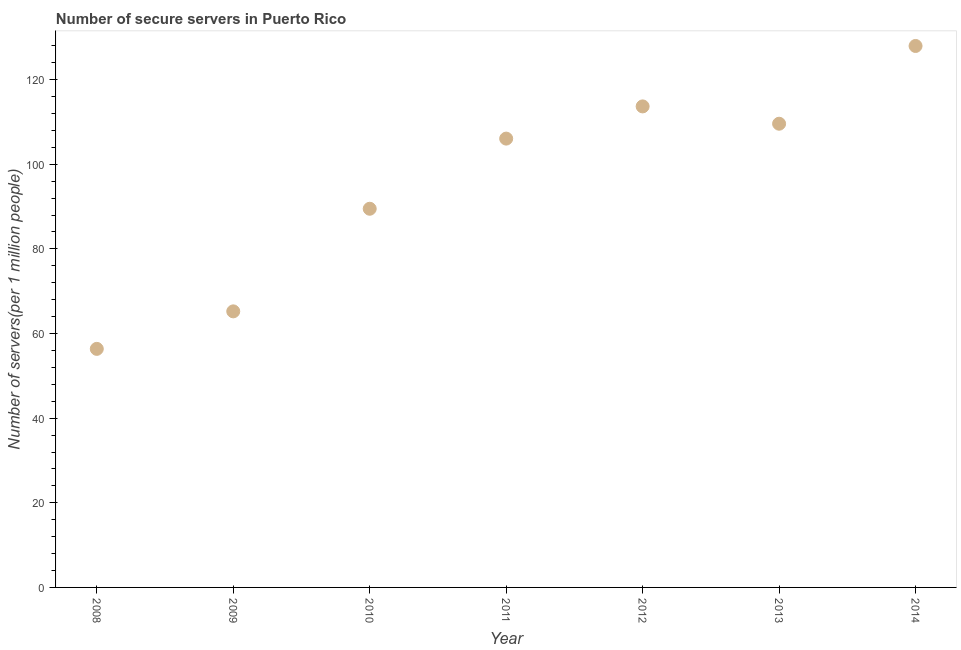What is the number of secure internet servers in 2014?
Your answer should be very brief. 127.95. Across all years, what is the maximum number of secure internet servers?
Provide a short and direct response. 127.95. Across all years, what is the minimum number of secure internet servers?
Offer a terse response. 56.37. In which year was the number of secure internet servers maximum?
Your response must be concise. 2014. In which year was the number of secure internet servers minimum?
Make the answer very short. 2008. What is the sum of the number of secure internet servers?
Your response must be concise. 668.32. What is the difference between the number of secure internet servers in 2010 and 2013?
Ensure brevity in your answer.  -20.09. What is the average number of secure internet servers per year?
Offer a terse response. 95.47. What is the median number of secure internet servers?
Your answer should be compact. 106.05. In how many years, is the number of secure internet servers greater than 104 ?
Your response must be concise. 4. Do a majority of the years between 2012 and 2010 (inclusive) have number of secure internet servers greater than 56 ?
Ensure brevity in your answer.  No. What is the ratio of the number of secure internet servers in 2009 to that in 2012?
Your answer should be compact. 0.57. What is the difference between the highest and the second highest number of secure internet servers?
Provide a succinct answer. 14.28. Is the sum of the number of secure internet servers in 2009 and 2013 greater than the maximum number of secure internet servers across all years?
Your answer should be very brief. Yes. What is the difference between the highest and the lowest number of secure internet servers?
Provide a short and direct response. 71.58. Does the number of secure internet servers monotonically increase over the years?
Keep it short and to the point. No. How many dotlines are there?
Your answer should be compact. 1. Are the values on the major ticks of Y-axis written in scientific E-notation?
Give a very brief answer. No. Does the graph contain any zero values?
Keep it short and to the point. No. Does the graph contain grids?
Keep it short and to the point. No. What is the title of the graph?
Ensure brevity in your answer.  Number of secure servers in Puerto Rico. What is the label or title of the Y-axis?
Give a very brief answer. Number of servers(per 1 million people). What is the Number of servers(per 1 million people) in 2008?
Make the answer very short. 56.37. What is the Number of servers(per 1 million people) in 2009?
Your answer should be very brief. 65.23. What is the Number of servers(per 1 million people) in 2010?
Your response must be concise. 89.48. What is the Number of servers(per 1 million people) in 2011?
Your answer should be very brief. 106.05. What is the Number of servers(per 1 million people) in 2012?
Keep it short and to the point. 113.67. What is the Number of servers(per 1 million people) in 2013?
Give a very brief answer. 109.57. What is the Number of servers(per 1 million people) in 2014?
Give a very brief answer. 127.95. What is the difference between the Number of servers(per 1 million people) in 2008 and 2009?
Make the answer very short. -8.86. What is the difference between the Number of servers(per 1 million people) in 2008 and 2010?
Provide a short and direct response. -33.11. What is the difference between the Number of servers(per 1 million people) in 2008 and 2011?
Offer a terse response. -49.68. What is the difference between the Number of servers(per 1 million people) in 2008 and 2012?
Your response must be concise. -57.3. What is the difference between the Number of servers(per 1 million people) in 2008 and 2013?
Provide a short and direct response. -53.2. What is the difference between the Number of servers(per 1 million people) in 2008 and 2014?
Offer a very short reply. -71.58. What is the difference between the Number of servers(per 1 million people) in 2009 and 2010?
Offer a very short reply. -24.25. What is the difference between the Number of servers(per 1 million people) in 2009 and 2011?
Keep it short and to the point. -40.82. What is the difference between the Number of servers(per 1 million people) in 2009 and 2012?
Offer a terse response. -48.43. What is the difference between the Number of servers(per 1 million people) in 2009 and 2013?
Ensure brevity in your answer.  -44.34. What is the difference between the Number of servers(per 1 million people) in 2009 and 2014?
Your answer should be very brief. -62.71. What is the difference between the Number of servers(per 1 million people) in 2010 and 2011?
Provide a succinct answer. -16.58. What is the difference between the Number of servers(per 1 million people) in 2010 and 2012?
Your answer should be compact. -24.19. What is the difference between the Number of servers(per 1 million people) in 2010 and 2013?
Give a very brief answer. -20.09. What is the difference between the Number of servers(per 1 million people) in 2010 and 2014?
Give a very brief answer. -38.47. What is the difference between the Number of servers(per 1 million people) in 2011 and 2012?
Make the answer very short. -7.61. What is the difference between the Number of servers(per 1 million people) in 2011 and 2013?
Your answer should be compact. -3.52. What is the difference between the Number of servers(per 1 million people) in 2011 and 2014?
Offer a very short reply. -21.89. What is the difference between the Number of servers(per 1 million people) in 2012 and 2013?
Offer a terse response. 4.09. What is the difference between the Number of servers(per 1 million people) in 2012 and 2014?
Make the answer very short. -14.28. What is the difference between the Number of servers(per 1 million people) in 2013 and 2014?
Your response must be concise. -18.37. What is the ratio of the Number of servers(per 1 million people) in 2008 to that in 2009?
Offer a very short reply. 0.86. What is the ratio of the Number of servers(per 1 million people) in 2008 to that in 2010?
Offer a very short reply. 0.63. What is the ratio of the Number of servers(per 1 million people) in 2008 to that in 2011?
Offer a terse response. 0.53. What is the ratio of the Number of servers(per 1 million people) in 2008 to that in 2012?
Provide a succinct answer. 0.5. What is the ratio of the Number of servers(per 1 million people) in 2008 to that in 2013?
Your response must be concise. 0.51. What is the ratio of the Number of servers(per 1 million people) in 2008 to that in 2014?
Ensure brevity in your answer.  0.44. What is the ratio of the Number of servers(per 1 million people) in 2009 to that in 2010?
Provide a succinct answer. 0.73. What is the ratio of the Number of servers(per 1 million people) in 2009 to that in 2011?
Give a very brief answer. 0.61. What is the ratio of the Number of servers(per 1 million people) in 2009 to that in 2012?
Your answer should be very brief. 0.57. What is the ratio of the Number of servers(per 1 million people) in 2009 to that in 2013?
Offer a very short reply. 0.59. What is the ratio of the Number of servers(per 1 million people) in 2009 to that in 2014?
Your response must be concise. 0.51. What is the ratio of the Number of servers(per 1 million people) in 2010 to that in 2011?
Your response must be concise. 0.84. What is the ratio of the Number of servers(per 1 million people) in 2010 to that in 2012?
Your answer should be very brief. 0.79. What is the ratio of the Number of servers(per 1 million people) in 2010 to that in 2013?
Offer a terse response. 0.82. What is the ratio of the Number of servers(per 1 million people) in 2010 to that in 2014?
Make the answer very short. 0.7. What is the ratio of the Number of servers(per 1 million people) in 2011 to that in 2012?
Make the answer very short. 0.93. What is the ratio of the Number of servers(per 1 million people) in 2011 to that in 2013?
Provide a short and direct response. 0.97. What is the ratio of the Number of servers(per 1 million people) in 2011 to that in 2014?
Offer a terse response. 0.83. What is the ratio of the Number of servers(per 1 million people) in 2012 to that in 2013?
Your answer should be very brief. 1.04. What is the ratio of the Number of servers(per 1 million people) in 2012 to that in 2014?
Offer a very short reply. 0.89. What is the ratio of the Number of servers(per 1 million people) in 2013 to that in 2014?
Your answer should be very brief. 0.86. 